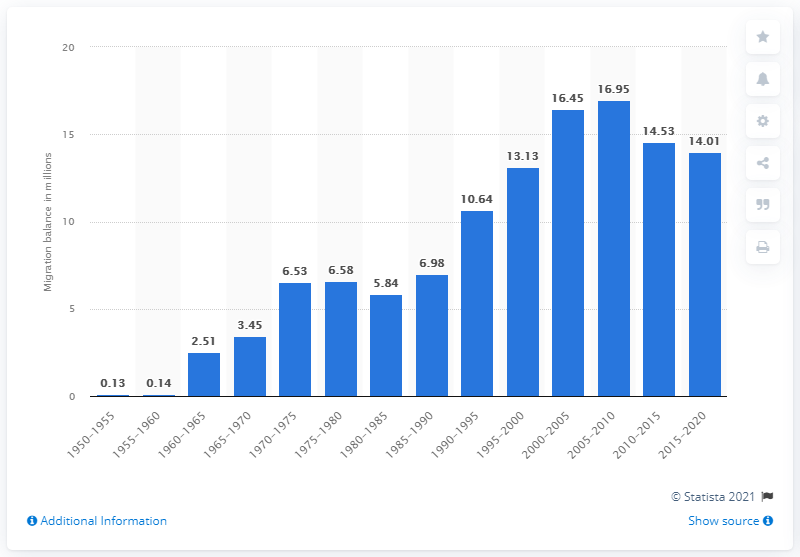Specify some key components in this picture. During the period of 2015 to 2020, an estimated 14.01 million people migrated from less developed regions to developed regions. 